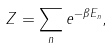Convert formula to latex. <formula><loc_0><loc_0><loc_500><loc_500>Z = \sum _ { n } e ^ { - \beta E _ { n } } ,</formula> 